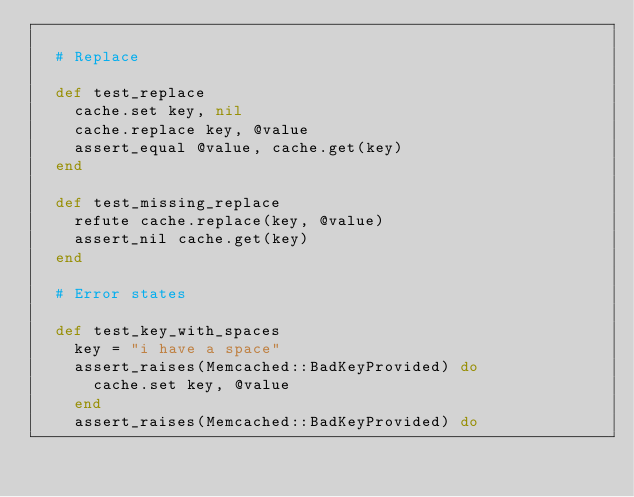<code> <loc_0><loc_0><loc_500><loc_500><_Ruby_>
  # Replace

  def test_replace
    cache.set key, nil
    cache.replace key, @value
    assert_equal @value, cache.get(key)
  end

  def test_missing_replace
    refute cache.replace(key, @value)
    assert_nil cache.get(key)
  end

  # Error states

  def test_key_with_spaces
    key = "i have a space"
    assert_raises(Memcached::BadKeyProvided) do
      cache.set key, @value
    end
    assert_raises(Memcached::BadKeyProvided) do</code> 